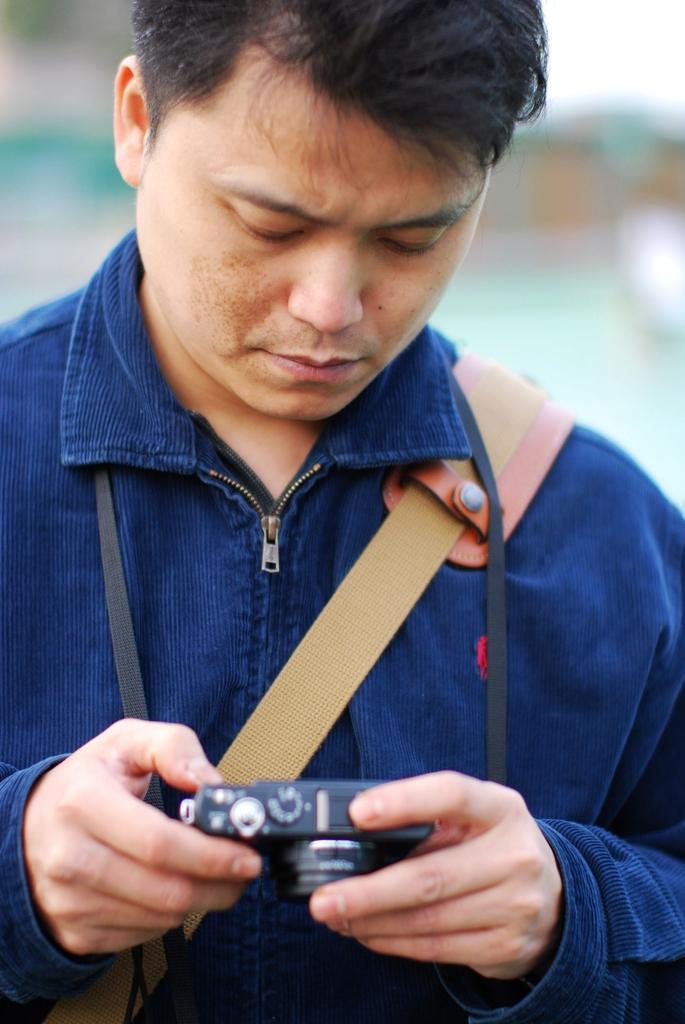Can you describe this image briefly? In this image there is a person wearing blue color shirt carrying bag and holding camera in his hands. 